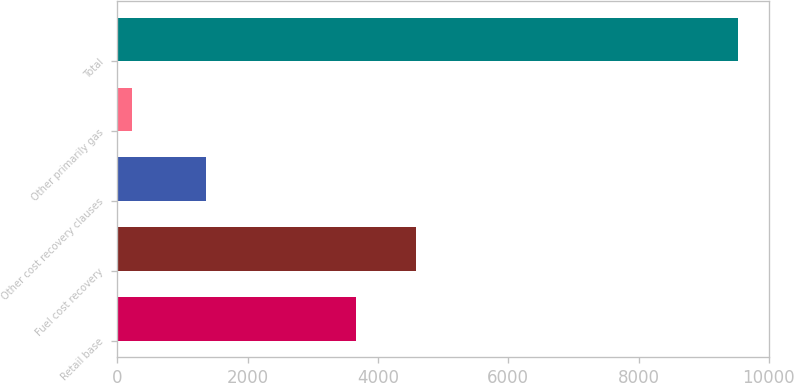<chart> <loc_0><loc_0><loc_500><loc_500><bar_chart><fcel>Retail base<fcel>Fuel cost recovery<fcel>Other cost recovery clauses<fcel>Other primarily gas<fcel>Total<nl><fcel>3658<fcel>4588.9<fcel>1368<fcel>219<fcel>9528<nl></chart> 